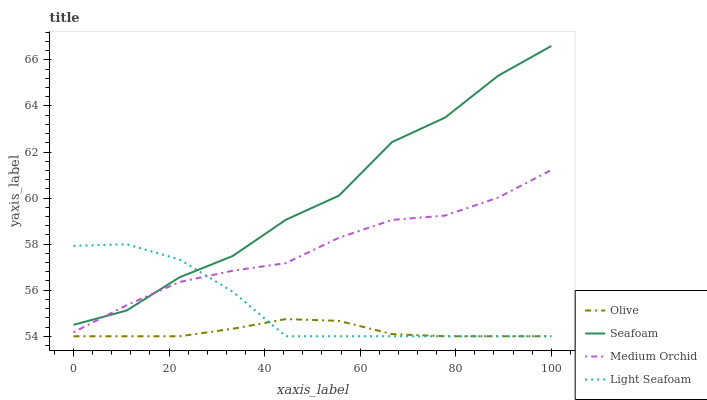Does Olive have the minimum area under the curve?
Answer yes or no. Yes. Does Seafoam have the maximum area under the curve?
Answer yes or no. Yes. Does Medium Orchid have the minimum area under the curve?
Answer yes or no. No. Does Medium Orchid have the maximum area under the curve?
Answer yes or no. No. Is Olive the smoothest?
Answer yes or no. Yes. Is Seafoam the roughest?
Answer yes or no. Yes. Is Medium Orchid the smoothest?
Answer yes or no. No. Is Medium Orchid the roughest?
Answer yes or no. No. Does Olive have the lowest value?
Answer yes or no. Yes. Does Medium Orchid have the lowest value?
Answer yes or no. No. Does Seafoam have the highest value?
Answer yes or no. Yes. Does Medium Orchid have the highest value?
Answer yes or no. No. Is Olive less than Seafoam?
Answer yes or no. Yes. Is Medium Orchid greater than Olive?
Answer yes or no. Yes. Does Light Seafoam intersect Olive?
Answer yes or no. Yes. Is Light Seafoam less than Olive?
Answer yes or no. No. Is Light Seafoam greater than Olive?
Answer yes or no. No. Does Olive intersect Seafoam?
Answer yes or no. No. 